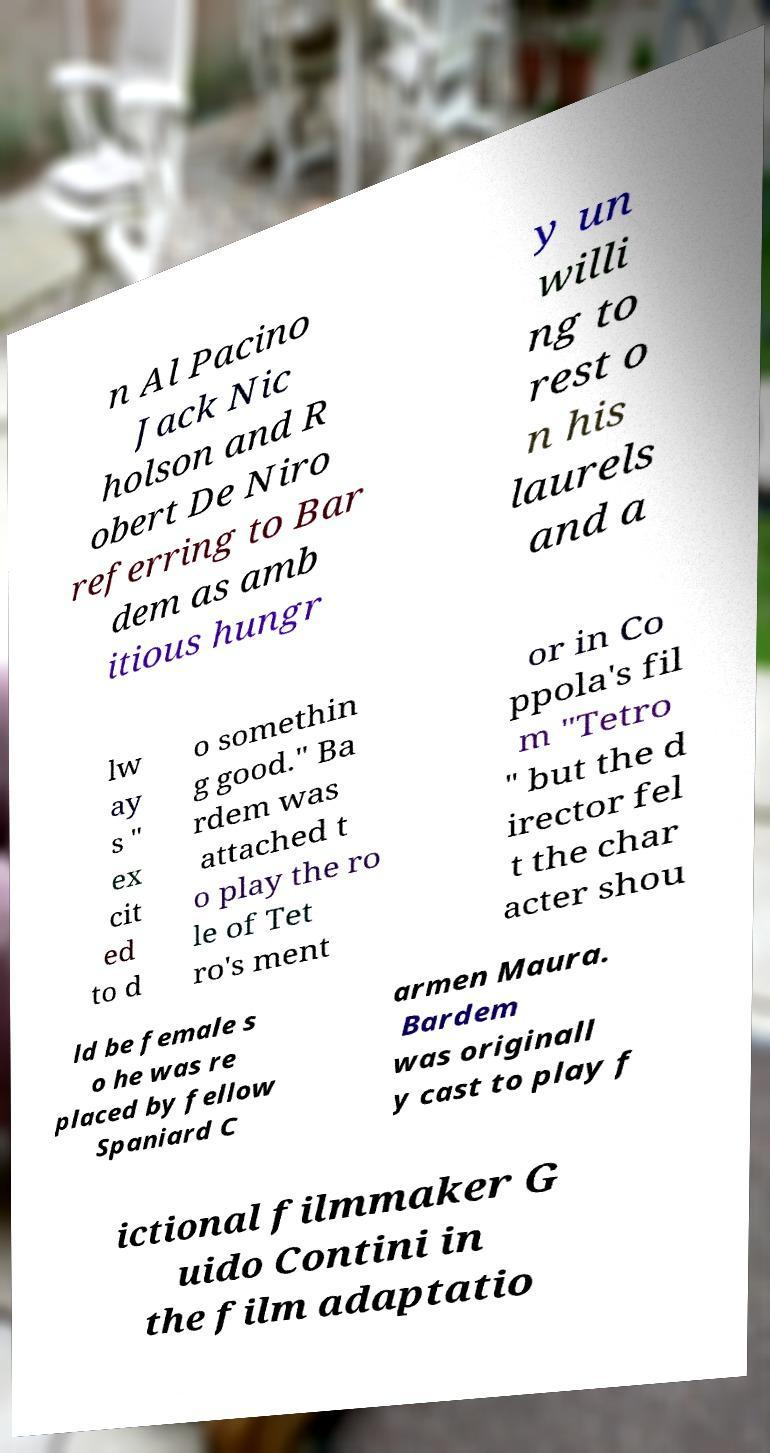Please identify and transcribe the text found in this image. n Al Pacino Jack Nic holson and R obert De Niro referring to Bar dem as amb itious hungr y un willi ng to rest o n his laurels and a lw ay s " ex cit ed to d o somethin g good." Ba rdem was attached t o play the ro le of Tet ro's ment or in Co ppola's fil m "Tetro " but the d irector fel t the char acter shou ld be female s o he was re placed by fellow Spaniard C armen Maura. Bardem was originall y cast to play f ictional filmmaker G uido Contini in the film adaptatio 